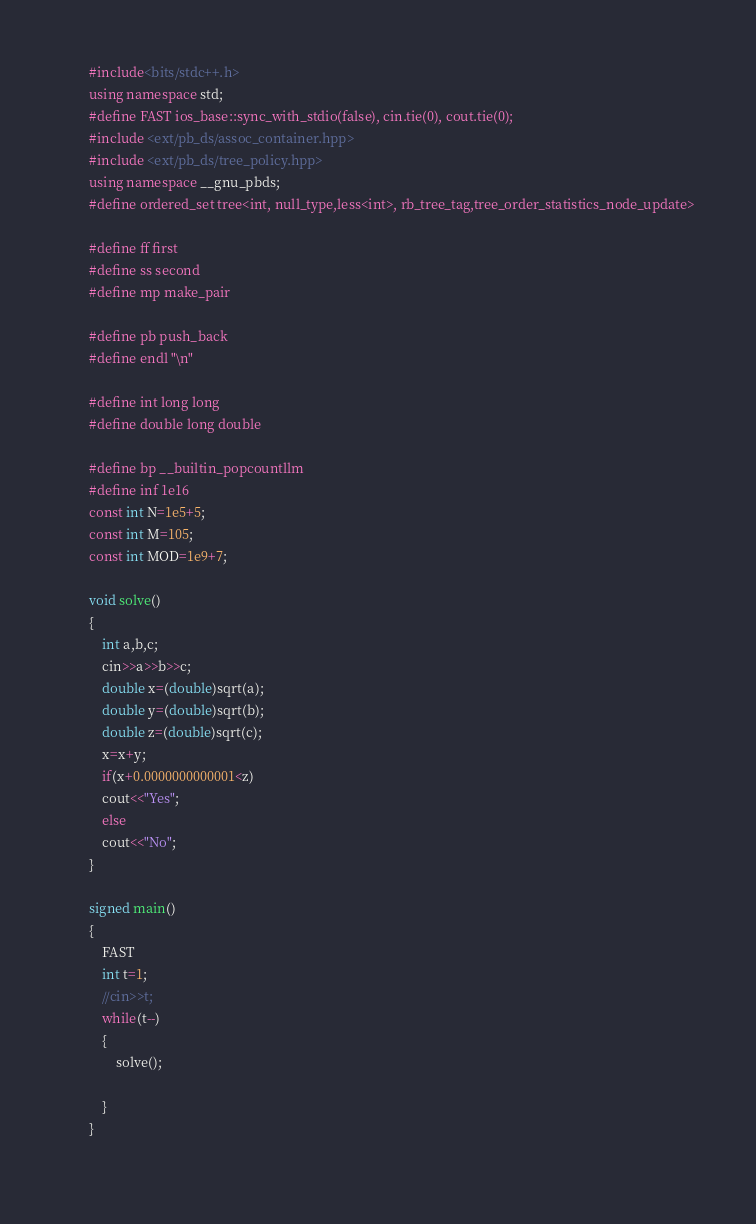Convert code to text. <code><loc_0><loc_0><loc_500><loc_500><_C++_>		#include<bits/stdc++.h>
		using namespace std;
		#define FAST ios_base::sync_with_stdio(false), cin.tie(0), cout.tie(0);
		#include <ext/pb_ds/assoc_container.hpp> 
		#include <ext/pb_ds/tree_policy.hpp> 
		using namespace __gnu_pbds; 
		#define ordered_set tree<int, null_type,less<int>, rb_tree_tag,tree_order_statistics_node_update>
		 
		#define ff first
		#define ss second
		#define mp make_pair
		 
		#define pb push_back
		#define endl "\n"
		 
		#define int long long 
		#define double long double
		 
		#define bp __builtin_popcountllm
		#define inf 1e16
		const int N=1e5+5;
		const int M=105;
		const int MOD=1e9+7;
	
		void solve()
		{	
			int a,b,c;
			cin>>a>>b>>c;
			double x=(double)sqrt(a);
			double y=(double)sqrt(b);
			double z=(double)sqrt(c);
			x=x+y;
			if(x+0.0000000000001<z)
			cout<<"Yes";
			else
			cout<<"No";
		}

		signed main()  
		{
			FAST
			int t=1;
			//cin>>t;
			while(t--)
			{
				solve();
				
			}
		}
		
</code> 